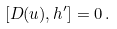Convert formula to latex. <formula><loc_0><loc_0><loc_500><loc_500>[ D ( u ) , h ^ { \prime } ] = 0 \, .</formula> 